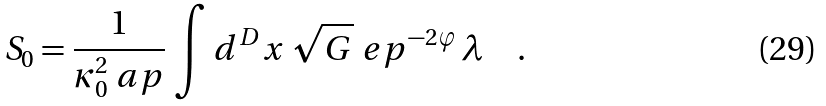Convert formula to latex. <formula><loc_0><loc_0><loc_500><loc_500>S _ { 0 } = \frac { 1 } { \kappa _ { 0 } ^ { 2 } \ a p } \, \int d ^ { D } x \, \sqrt { G } \ e p ^ { - 2 \varphi } \, \lambda \quad .</formula> 